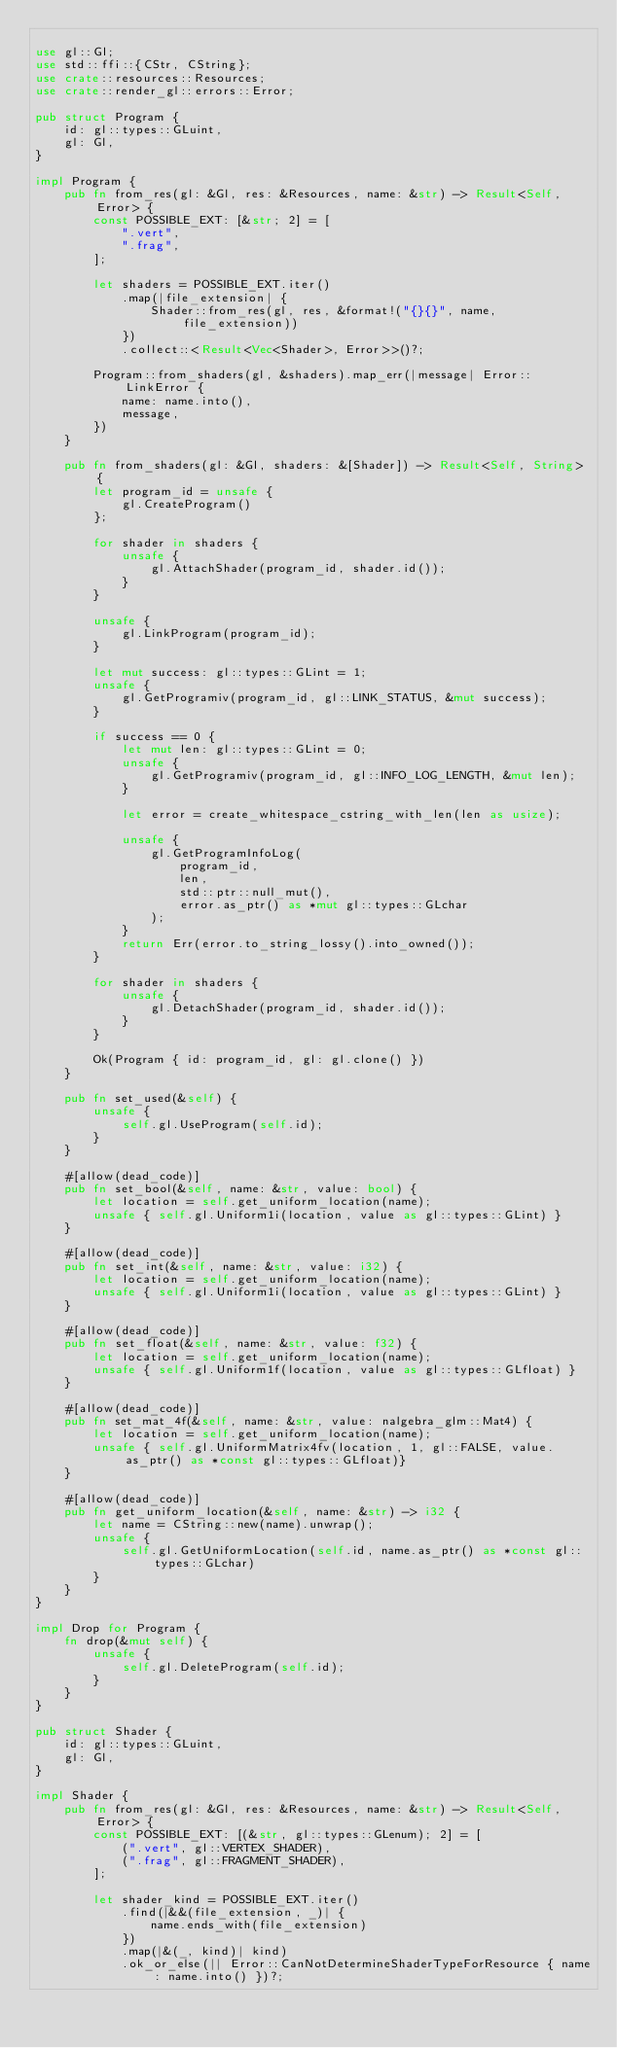Convert code to text. <code><loc_0><loc_0><loc_500><loc_500><_Rust_>
use gl::Gl;
use std::ffi::{CStr, CString};
use crate::resources::Resources;
use crate::render_gl::errors::Error;

pub struct Program {
    id: gl::types::GLuint,
    gl: Gl,
}

impl Program {
    pub fn from_res(gl: &Gl, res: &Resources, name: &str) -> Result<Self, Error> {
        const POSSIBLE_EXT: [&str; 2] = [
            ".vert",
            ".frag",
        ];

        let shaders = POSSIBLE_EXT.iter()
            .map(|file_extension| {
                Shader::from_res(gl, res, &format!("{}{}", name, file_extension))
            })
            .collect::<Result<Vec<Shader>, Error>>()?;

        Program::from_shaders(gl, &shaders).map_err(|message| Error::LinkError {
            name: name.into(),
            message,
        })
    }

    pub fn from_shaders(gl: &Gl, shaders: &[Shader]) -> Result<Self, String> {
        let program_id = unsafe {
            gl.CreateProgram()
        };

        for shader in shaders {
            unsafe {
                gl.AttachShader(program_id, shader.id());
            }
        }

        unsafe {
            gl.LinkProgram(program_id);
        }

        let mut success: gl::types::GLint = 1;
        unsafe {
            gl.GetProgramiv(program_id, gl::LINK_STATUS, &mut success);
        }

        if success == 0 {
            let mut len: gl::types::GLint = 0;
            unsafe {
                gl.GetProgramiv(program_id, gl::INFO_LOG_LENGTH, &mut len);
            }

            let error = create_whitespace_cstring_with_len(len as usize);

            unsafe {
                gl.GetProgramInfoLog(
                    program_id,
                    len,
                    std::ptr::null_mut(),
                    error.as_ptr() as *mut gl::types::GLchar
                );
            }
            return Err(error.to_string_lossy().into_owned());
        }

        for shader in shaders {
            unsafe {
                gl.DetachShader(program_id, shader.id());
            }
        }

        Ok(Program { id: program_id, gl: gl.clone() })
    }

    pub fn set_used(&self) {
        unsafe {
            self.gl.UseProgram(self.id);
        }
    }

    #[allow(dead_code)]
    pub fn set_bool(&self, name: &str, value: bool) {
        let location = self.get_uniform_location(name);
        unsafe { self.gl.Uniform1i(location, value as gl::types::GLint) }
    }

    #[allow(dead_code)]
    pub fn set_int(&self, name: &str, value: i32) {
        let location = self.get_uniform_location(name);
        unsafe { self.gl.Uniform1i(location, value as gl::types::GLint) }
    }

    #[allow(dead_code)]
    pub fn set_float(&self, name: &str, value: f32) {
        let location = self.get_uniform_location(name);
        unsafe { self.gl.Uniform1f(location, value as gl::types::GLfloat) }
    }

    #[allow(dead_code)]
    pub fn set_mat_4f(&self, name: &str, value: nalgebra_glm::Mat4) {
        let location = self.get_uniform_location(name);
        unsafe { self.gl.UniformMatrix4fv(location, 1, gl::FALSE, value.as_ptr() as *const gl::types::GLfloat)}
    }

    #[allow(dead_code)]
    pub fn get_uniform_location(&self, name: &str) -> i32 {
        let name = CString::new(name).unwrap();
        unsafe {
            self.gl.GetUniformLocation(self.id, name.as_ptr() as *const gl::types::GLchar)
        }
    }
}

impl Drop for Program {
    fn drop(&mut self) {
        unsafe {
            self.gl.DeleteProgram(self.id);
        }
    }
}

pub struct Shader {
    id: gl::types::GLuint,
    gl: Gl,
}

impl Shader {
    pub fn from_res(gl: &Gl, res: &Resources, name: &str) -> Result<Self, Error> {
        const POSSIBLE_EXT: [(&str, gl::types::GLenum); 2] = [
            (".vert", gl::VERTEX_SHADER),
            (".frag", gl::FRAGMENT_SHADER),
        ];

        let shader_kind = POSSIBLE_EXT.iter()
            .find(|&&(file_extension, _)| {
                name.ends_with(file_extension)
            })
            .map(|&(_, kind)| kind)
            .ok_or_else(|| Error::CanNotDetermineShaderTypeForResource { name: name.into() })?;</code> 